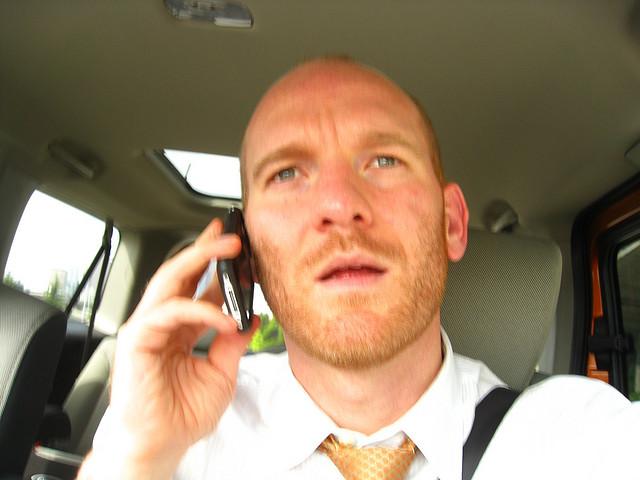Is his top button open?
Concise answer only. No. What does the man have in his hand?
Concise answer only. Phone. Is this man breaking any laws?
Answer briefly. Yes. 